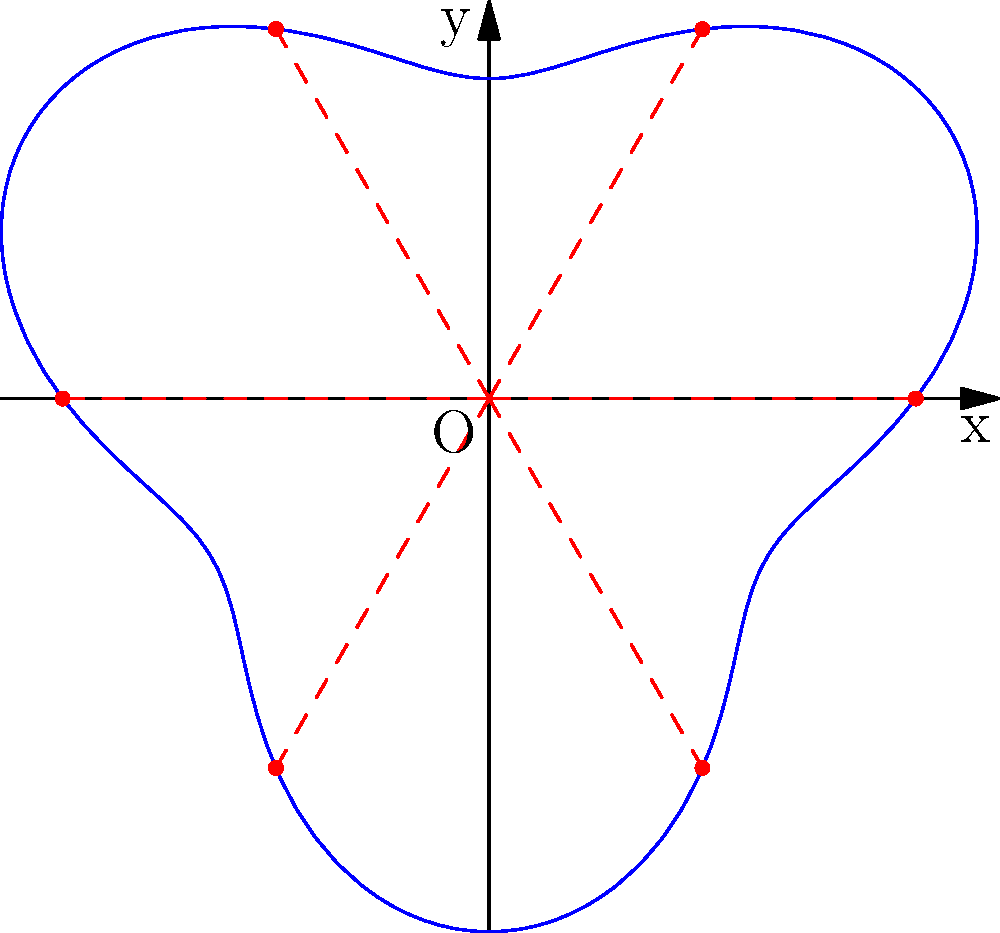A circular gear experiences varying stress distribution along its circumference. The stress $\sigma(\theta)$ in polar coordinates is given by the equation:

$$\sigma(\theta) = 100 + 30\sin(3\theta) \text{ MPa}$$

Where $\theta$ is measured in radians. The gear's radius varies according to:

$$r(\theta) = 2 + 0.5\sin(3\theta) \text{ cm}$$

Determine the maximum stress experienced by the gear and at what angle(s) it occurs. To find the maximum stress and its corresponding angle(s), we need to follow these steps:

1) The stress function is given by $\sigma(\theta) = 100 + 30\sin(3\theta)$ MPa.

2) To find the maximum stress, we need to find the maximum value of $\sin(3\theta)$, which occurs when $\sin(3\theta) = 1$.

3) The maximum value of sine is 1, so the maximum stress is:
   $$\sigma_{max} = 100 + 30(1) = 130 \text{ MPa}$$

4) To find the angle(s) at which this occurs, we solve:
   $$\sin(3\theta) = 1$$

5) The general solution for this equation is:
   $$3\theta = \frac{\pi}{2} + 2\pi n, \text{ where } n \text{ is an integer}$$

6) Solving for $\theta$:
   $$\theta = \frac{\pi}{6} + \frac{2\pi n}{3}$$

7) In the interval $[0, 2\pi]$, this gives us two solutions:
   $$\theta_1 = \frac{\pi}{6} \approx 0.52 \text{ radians} \approx 30°$$
   $$\theta_2 = \frac{5\pi}{6} \approx 2.62 \text{ radians} \approx 150°$$

8) Note that the radius function $r(\theta)$ doesn't affect the stress distribution in this case, but it determines the shape of the gear as shown in the diagram.
Answer: 130 MPa at $\theta = \frac{\pi}{6}$ and $\frac{5\pi}{6}$ radians 